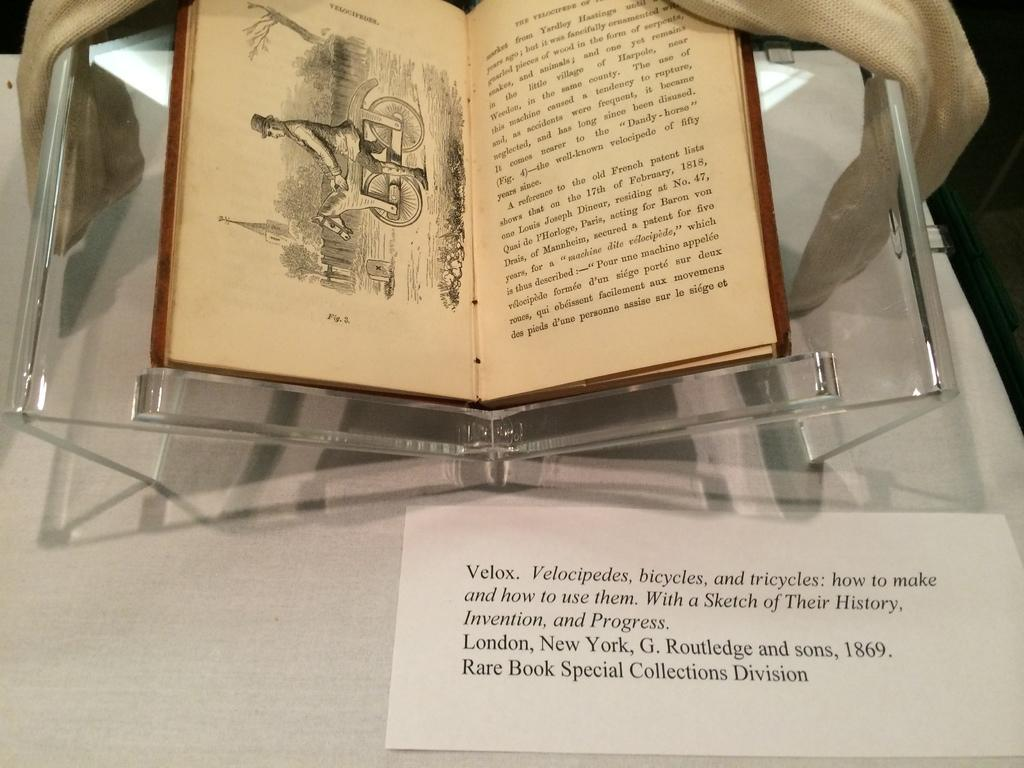Provide a one-sentence caption for the provided image. A copy of a rare book from 1869 called Velox displayed in a case. 